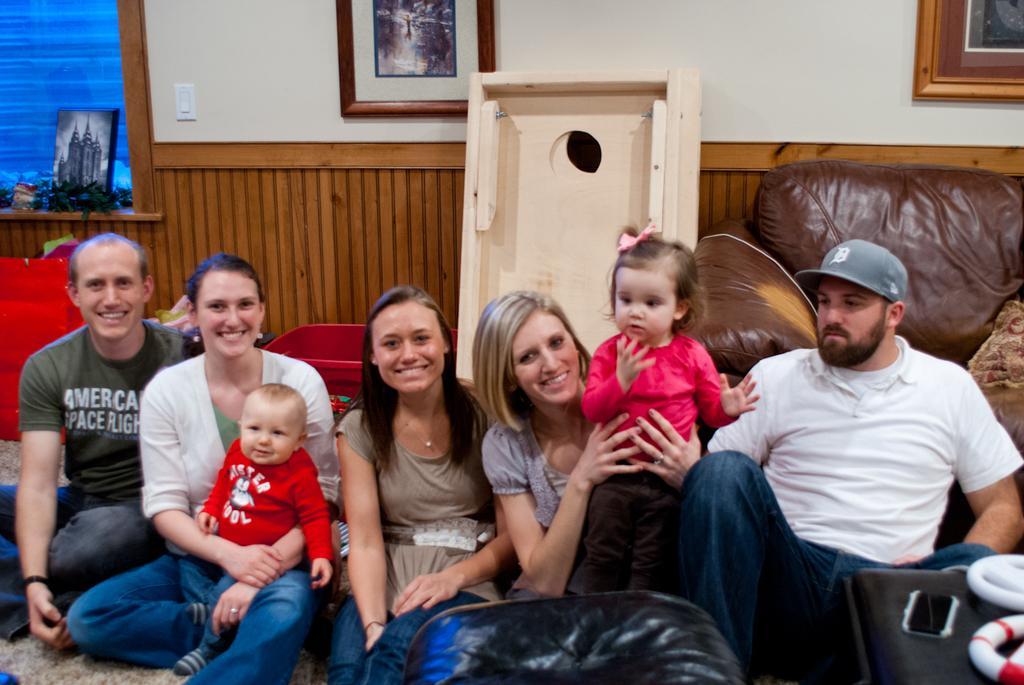What can be observed about the people in the image? There are people standing in the image. How many kids are present in the image? There are two kids in the image. What is visible in the background of the image? There is a wall with a photo frame in the background of the image. What type of lettuce is growing on the wall in the image? There is no lettuce present in the image; the background features a wall with a photo frame. Can you see any army personnel in the image? There is no mention of army personnel in the image; it features people, including two kids. 